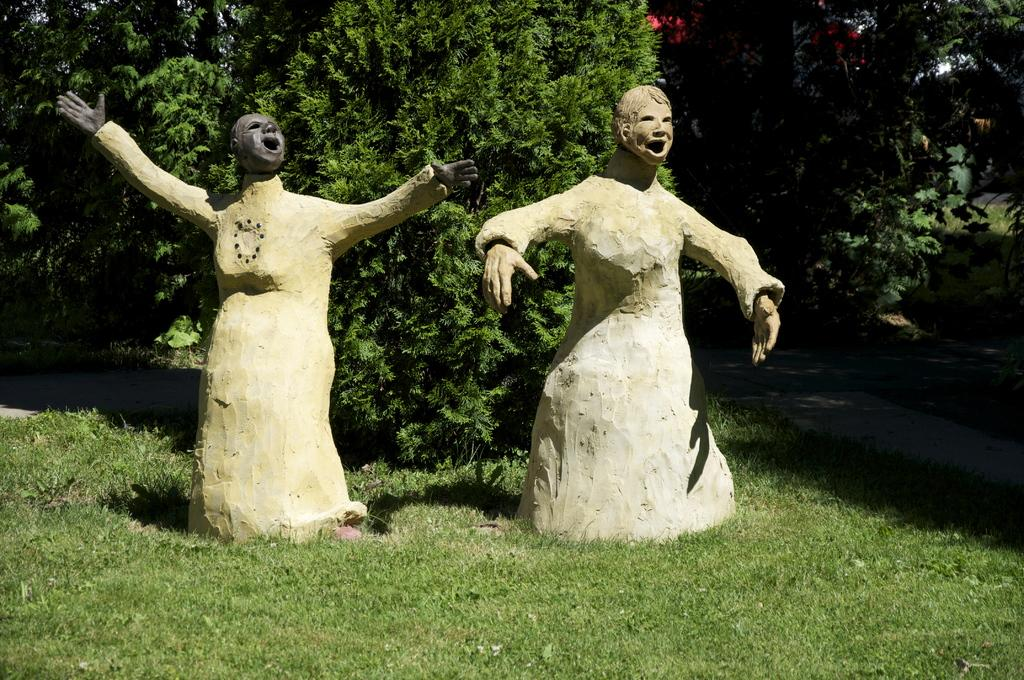How many statues are present in the image? There are two statues in the image. What is located at the bottom of the image? There is grass at the bottom of the image. What can be seen in the background of the image? There are trees in the background of the image. What type of poison is being used to protect the statues in the image? There is no mention of poison or any protective measures for the statues in the image. 